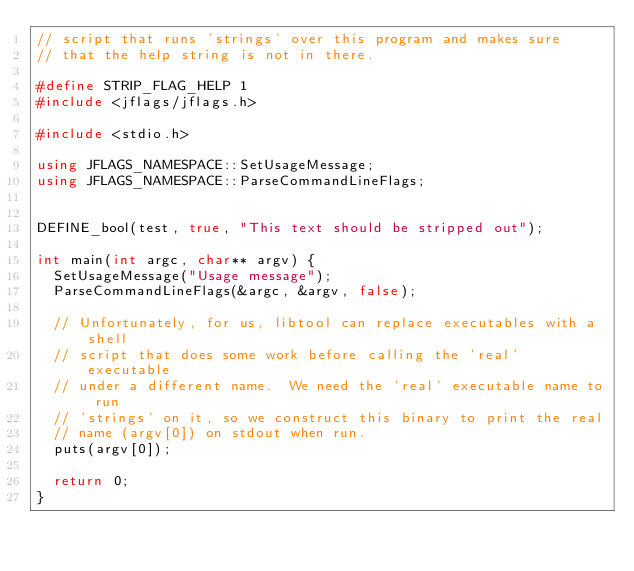Convert code to text. <code><loc_0><loc_0><loc_500><loc_500><_C++_>// script that runs 'strings' over this program and makes sure
// that the help string is not in there.

#define STRIP_FLAG_HELP 1
#include <jflags/jflags.h>

#include <stdio.h>

using JFLAGS_NAMESPACE::SetUsageMessage;
using JFLAGS_NAMESPACE::ParseCommandLineFlags;


DEFINE_bool(test, true, "This text should be stripped out");

int main(int argc, char** argv) {
  SetUsageMessage("Usage message");
  ParseCommandLineFlags(&argc, &argv, false);

  // Unfortunately, for us, libtool can replace executables with a shell
  // script that does some work before calling the 'real' executable
  // under a different name.  We need the 'real' executable name to run
  // 'strings' on it, so we construct this binary to print the real
  // name (argv[0]) on stdout when run.
  puts(argv[0]);

  return 0;
}
</code> 